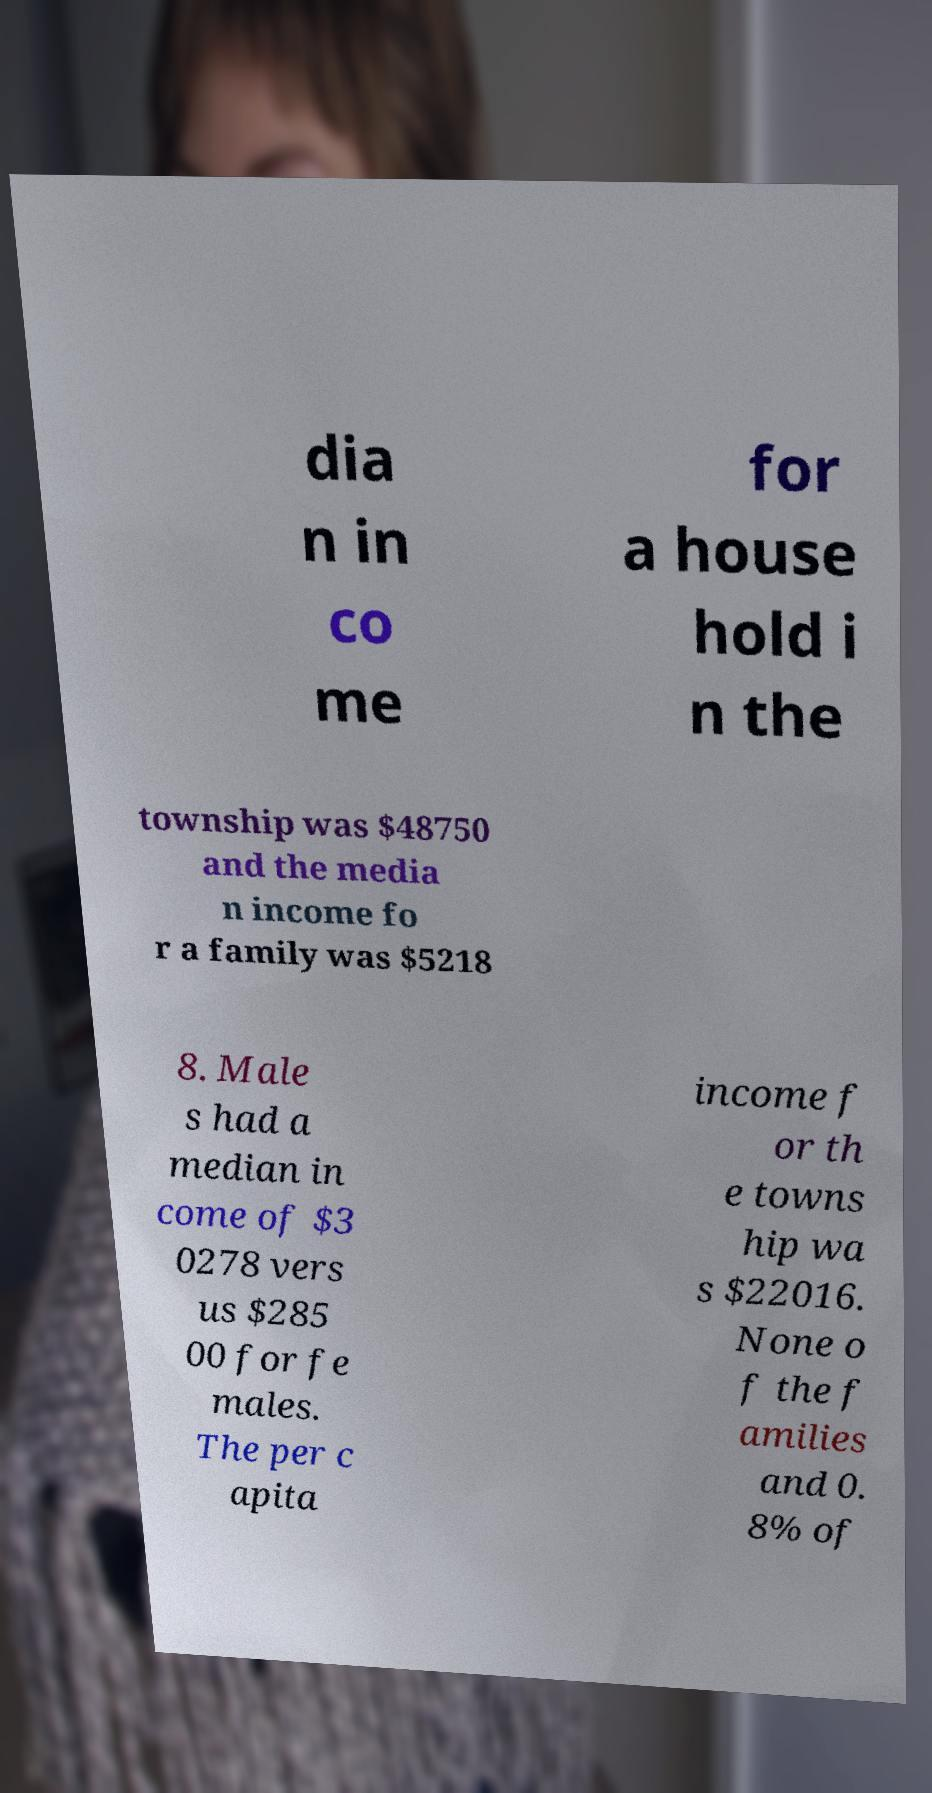I need the written content from this picture converted into text. Can you do that? dia n in co me for a house hold i n the township was $48750 and the media n income fo r a family was $5218 8. Male s had a median in come of $3 0278 vers us $285 00 for fe males. The per c apita income f or th e towns hip wa s $22016. None o f the f amilies and 0. 8% of 